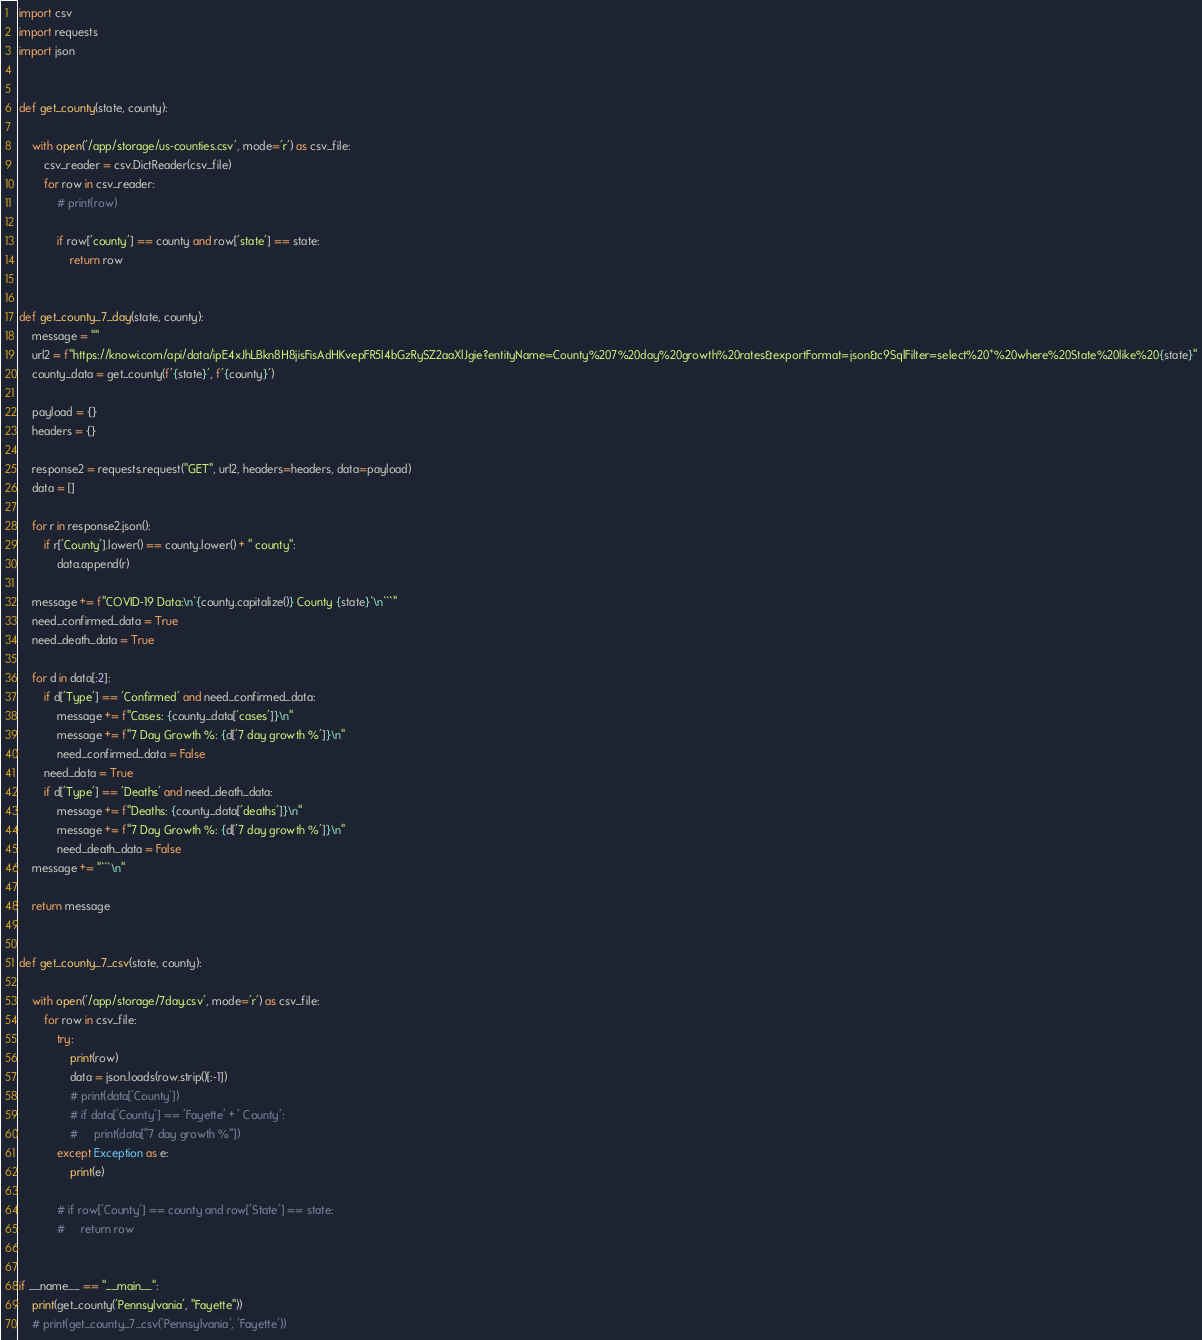Convert code to text. <code><loc_0><loc_0><loc_500><loc_500><_Python_>import csv
import requests
import json


def get_county(state, county):

    with open('/app/storage/us-counties.csv', mode='r') as csv_file:
        csv_reader = csv.DictReader(csv_file)
        for row in csv_reader:
            # print(row)

            if row['county'] == county and row['state'] == state:
                return row


def get_county_7_day(state, county):
    message = ""
    url2 = f"https://knowi.com/api/data/ipE4xJhLBkn8H8jisFisAdHKvepFR5I4bGzRySZ2aaXlJgie?entityName=County%207%20day%20growth%20rates&exportFormat=json&c9SqlFilter=select%20*%20where%20State%20like%20{state}"
    county_data = get_county(f'{state}', f'{county}')

    payload = {}
    headers = {}

    response2 = requests.request("GET", url2, headers=headers, data=payload)
    data = []

    for r in response2.json():
        if r['County'].lower() == county.lower() + " county":
            data.append(r)

    message += f"COVID-19 Data:\n`{county.capitalize()} County {state}`\n```"
    need_confirmed_data = True
    need_death_data = True

    for d in data[:2]:
        if d['Type'] == 'Confirmed' and need_confirmed_data:
            message += f"Cases: {county_data['cases']}\n"
            message += f"7 Day Growth %: {d['7 day growth %']}\n"
            need_confirmed_data = False
        need_data = True
        if d['Type'] == 'Deaths' and need_death_data:
            message += f"Deaths: {county_data['deaths']}\n"
            message += f"7 Day Growth %: {d['7 day growth %']}\n"
            need_death_data = False
    message += "```\n"

    return message


def get_county_7_csv(state, county):

    with open('/app/storage/7day.csv', mode='r') as csv_file:
        for row in csv_file:
            try:
                print(row)
                data = json.loads(row.strip()[:-1])
                # print(data['County'])
                # if data['County'] == 'Fayette' + ' County':
                #     print(data["7 day growth %"])
            except Exception as e:
                print(e)

            # if row['County'] == county and row['State'] == state:
            #     return row


if __name__ == "__main__":
    print(get_county('Pennsylvania', "Fayette"))
    # print(get_county_7_csv('Pennsylvania', 'Fayette'))
</code> 